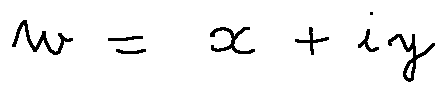<formula> <loc_0><loc_0><loc_500><loc_500>w = x + i y</formula> 